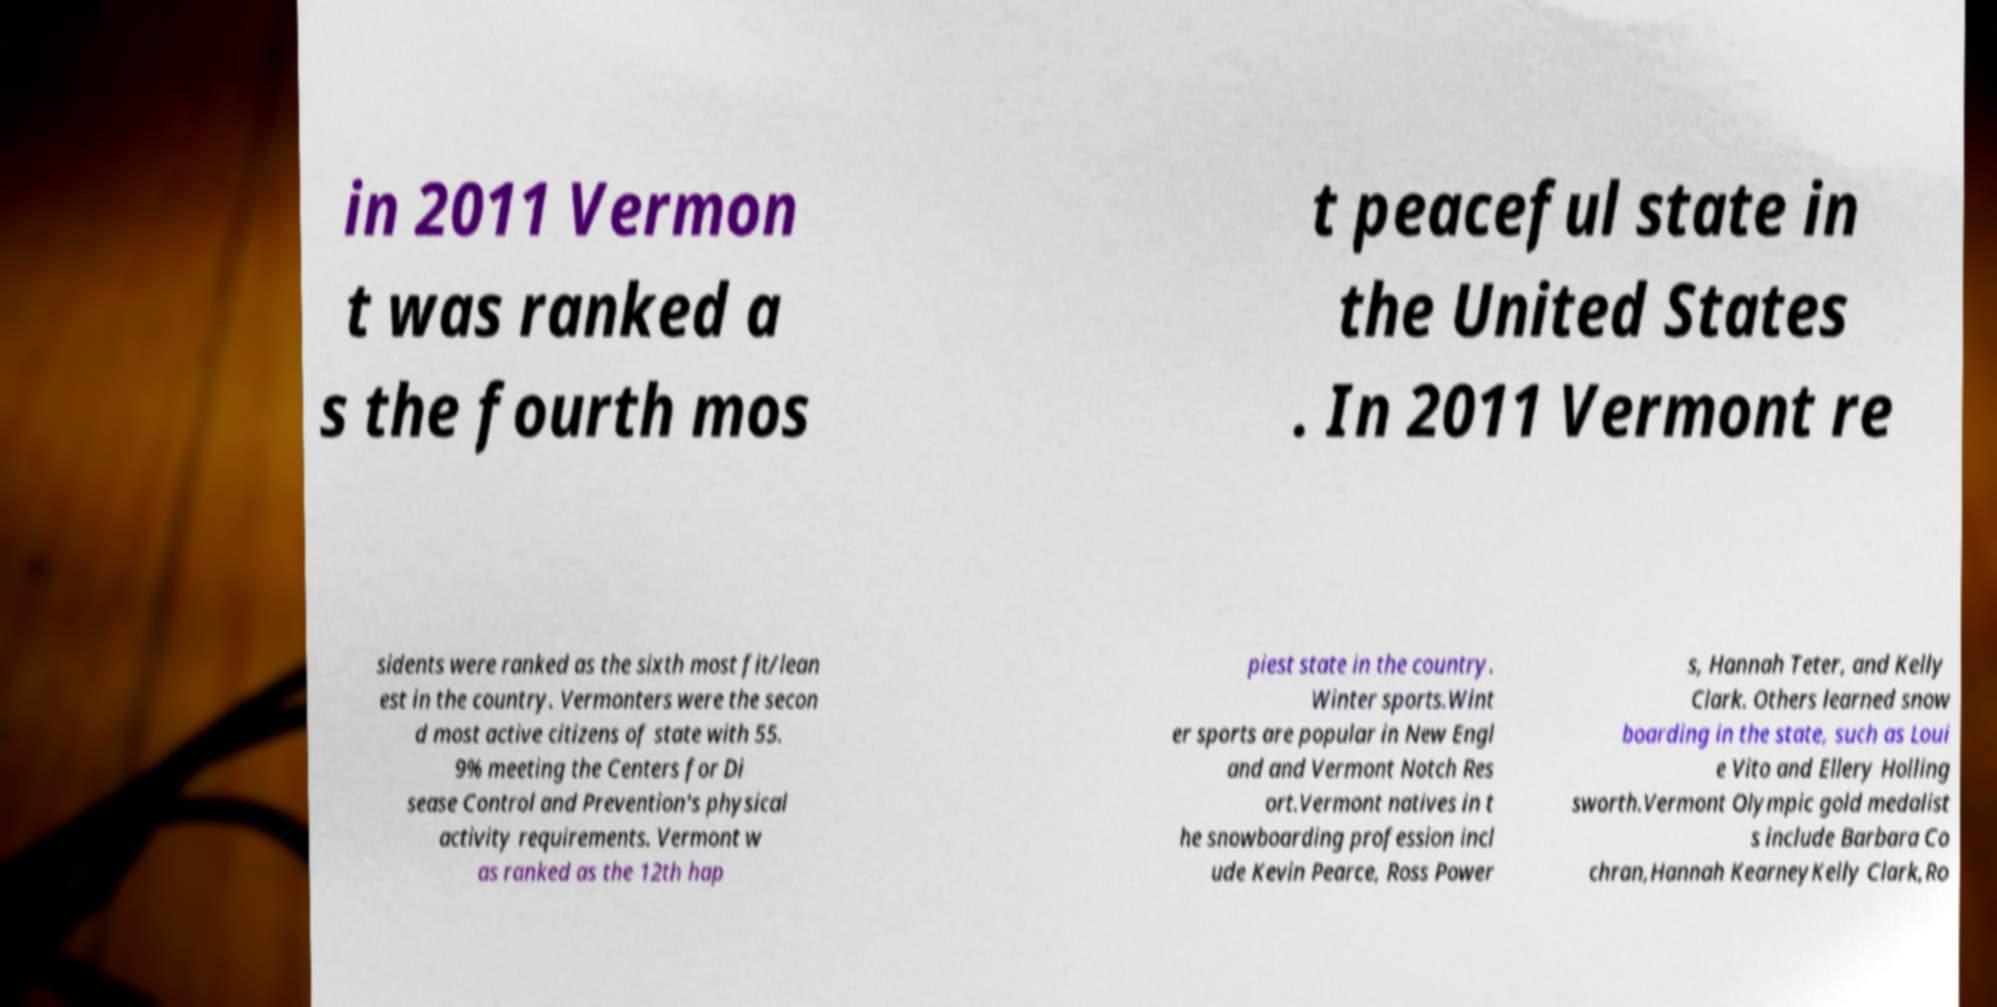Please identify and transcribe the text found in this image. in 2011 Vermon t was ranked a s the fourth mos t peaceful state in the United States . In 2011 Vermont re sidents were ranked as the sixth most fit/lean est in the country. Vermonters were the secon d most active citizens of state with 55. 9% meeting the Centers for Di sease Control and Prevention's physical activity requirements. Vermont w as ranked as the 12th hap piest state in the country. Winter sports.Wint er sports are popular in New Engl and and Vermont Notch Res ort.Vermont natives in t he snowboarding profession incl ude Kevin Pearce, Ross Power s, Hannah Teter, and Kelly Clark. Others learned snow boarding in the state, such as Loui e Vito and Ellery Holling sworth.Vermont Olympic gold medalist s include Barbara Co chran,Hannah KearneyKelly Clark,Ro 